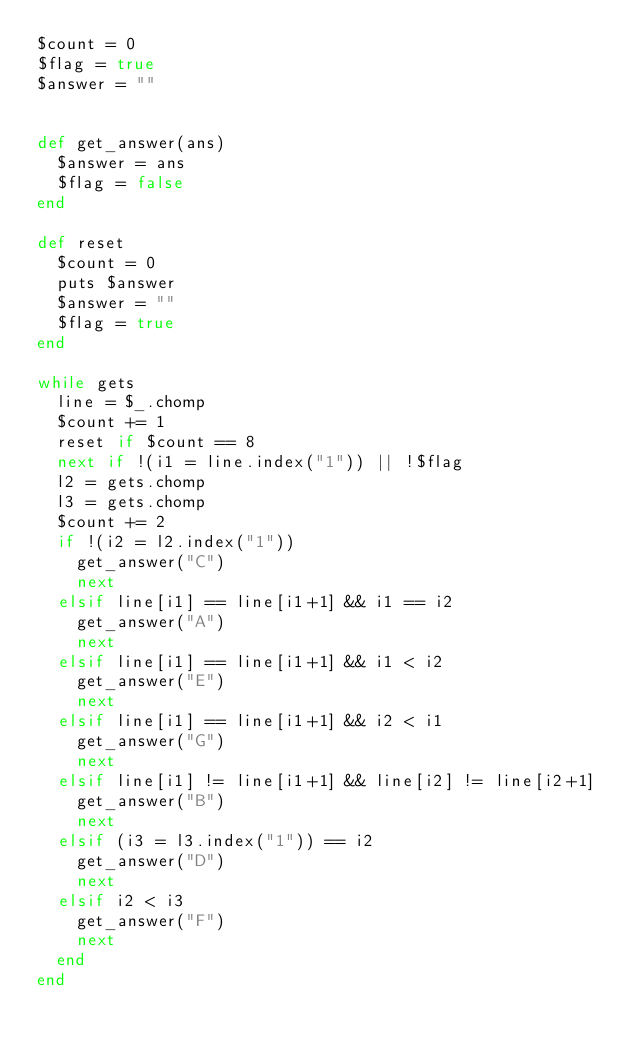<code> <loc_0><loc_0><loc_500><loc_500><_Ruby_>$count = 0
$flag = true
$answer = ""


def get_answer(ans)
	$answer = ans
	$flag = false
end

def reset
	$count = 0
	puts $answer
	$answer = ""
	$flag = true
end

while gets
	line = $_.chomp
	$count += 1
	reset if $count == 8
	next if !(i1 = line.index("1")) || !$flag
	l2 = gets.chomp
	l3 = gets.chomp
	$count += 2
	if !(i2 = l2.index("1"))
		get_answer("C")
		next
	elsif line[i1] == line[i1+1] && i1 == i2
		get_answer("A")
		next
	elsif line[i1] == line[i1+1] && i1 < i2
		get_answer("E")
		next
	elsif line[i1] == line[i1+1] && i2 < i1
		get_answer("G")
		next
	elsif line[i1] != line[i1+1] && line[i2] != line[i2+1]
		get_answer("B")
		next
	elsif (i3 = l3.index("1")) == i2
		get_answer("D")
		next
	elsif i2 < i3
		get_answer("F")
		next
	end
end</code> 